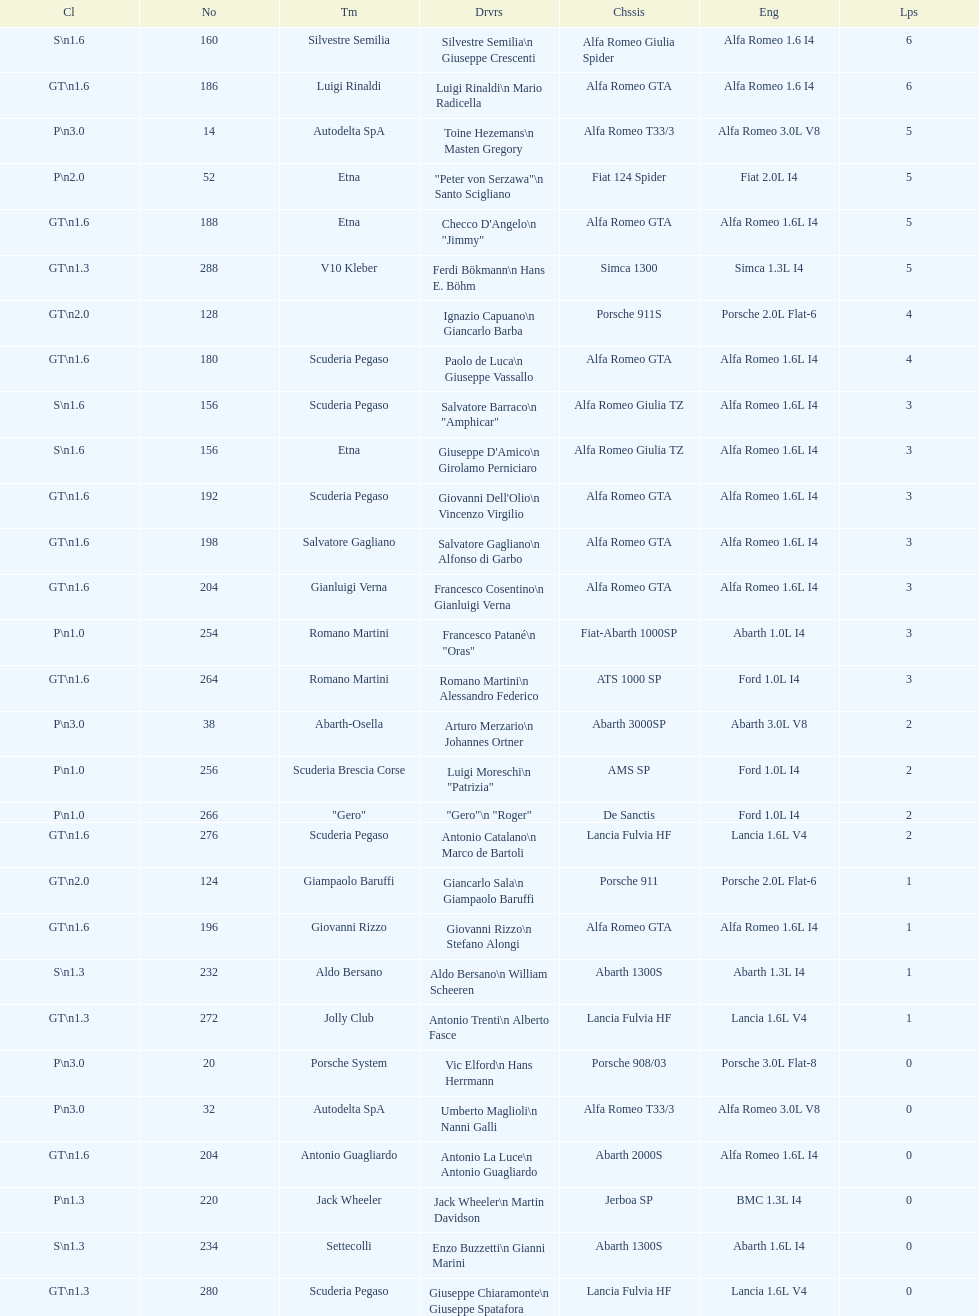How many laps does v10 kleber have? 5. 